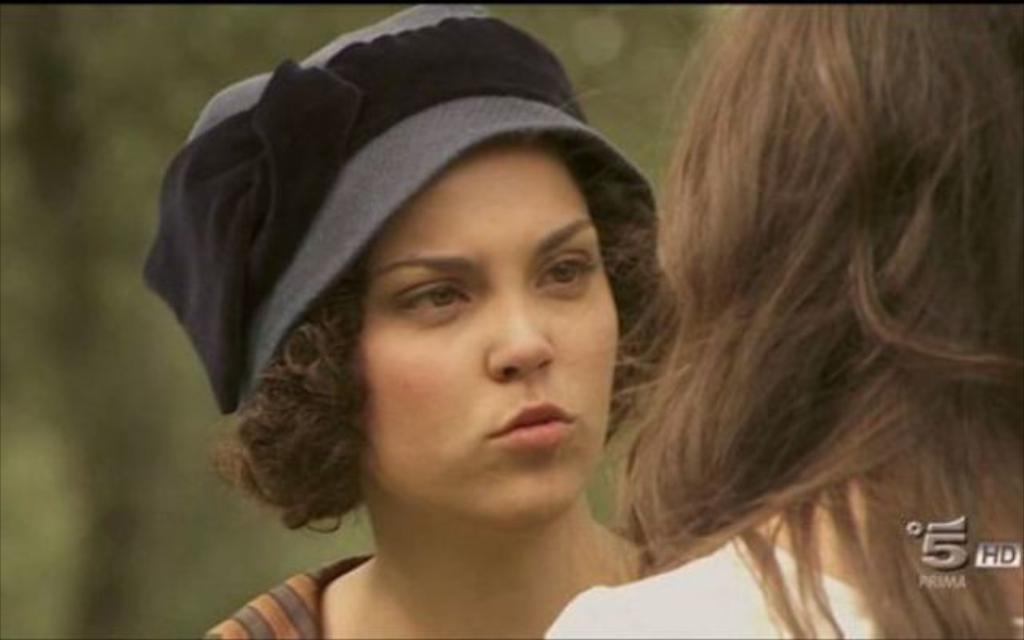In one or two sentences, can you explain what this image depicts? In this image I can see a woman wearing white colored dress and another woman wearing hat which is grey and black in color. In the background I can see few trees which are green in color. 